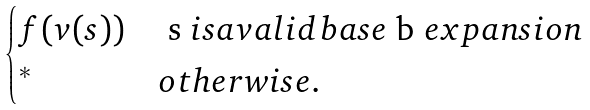Convert formula to latex. <formula><loc_0><loc_0><loc_500><loc_500>\begin{cases} f ( v ( s ) ) & $ s $ i s a v a l i d b a s e $ b $ e x p a n s i o n \\ ^ { * } & o t h e r w i s e . \end{cases}</formula> 